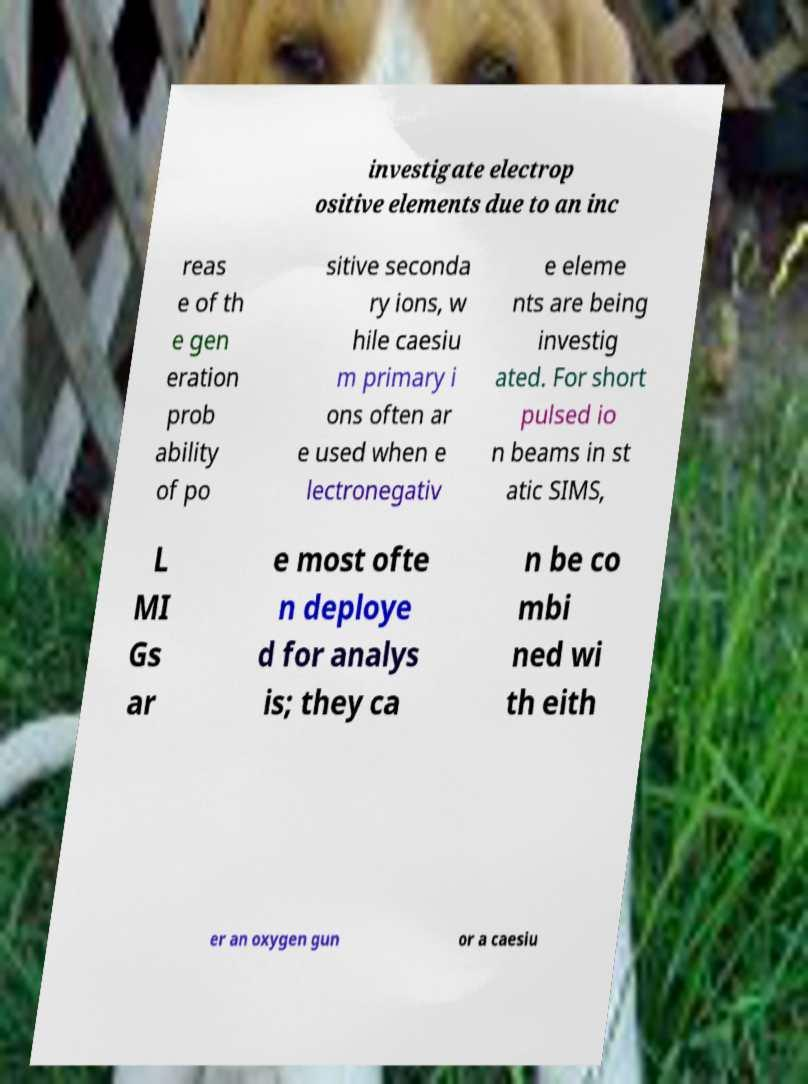Please identify and transcribe the text found in this image. investigate electrop ositive elements due to an inc reas e of th e gen eration prob ability of po sitive seconda ry ions, w hile caesiu m primary i ons often ar e used when e lectronegativ e eleme nts are being investig ated. For short pulsed io n beams in st atic SIMS, L MI Gs ar e most ofte n deploye d for analys is; they ca n be co mbi ned wi th eith er an oxygen gun or a caesiu 